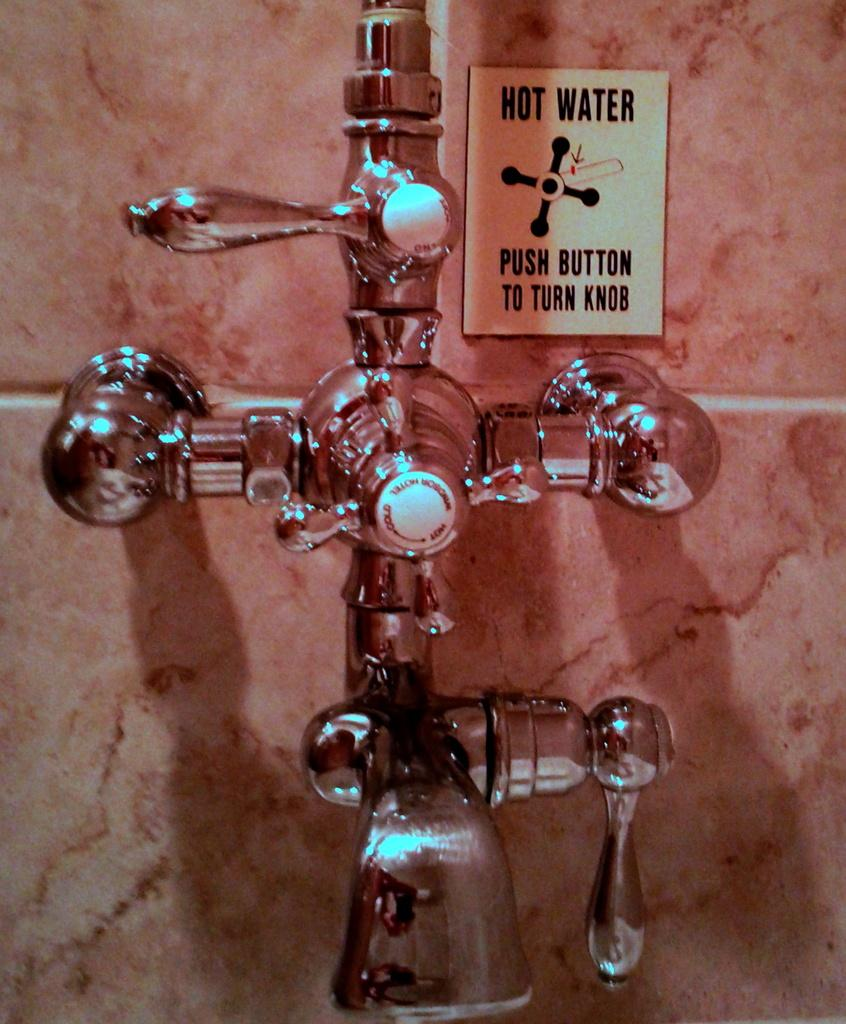What color is the wall in the image? The wall in the image is brown-colored. What type of fixtures are on the wall? There are metal taps on the wall. What is the color and pattern of the board in the image? The board is white and black in color. What type of trade is being conducted in the image? There is no trade being conducted in the image; it only features a brown-colored wall, metal taps, and a white and black board. What button is being pressed in the image? There is no button being pressed in the image. 